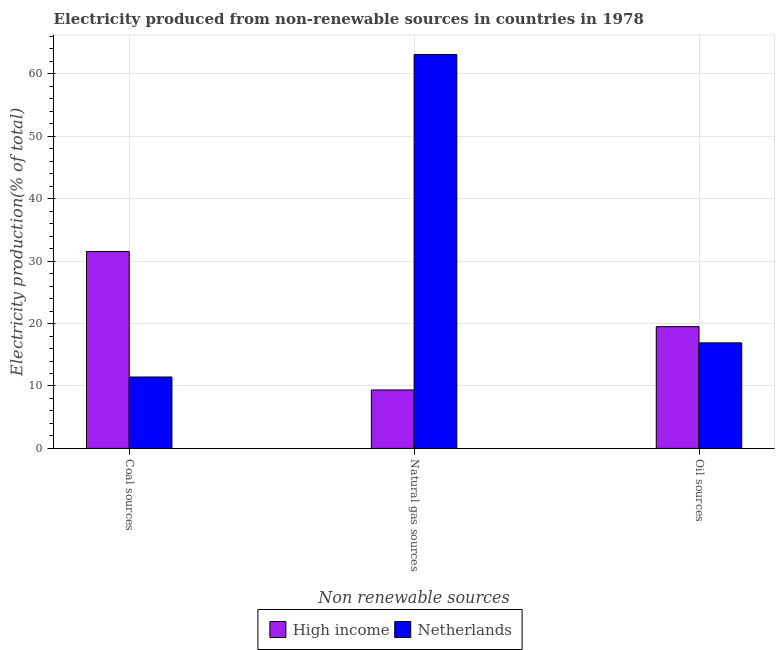How many different coloured bars are there?
Offer a very short reply. 2. What is the label of the 1st group of bars from the left?
Give a very brief answer. Coal sources. What is the percentage of electricity produced by coal in High income?
Offer a terse response. 31.54. Across all countries, what is the maximum percentage of electricity produced by coal?
Offer a very short reply. 31.54. Across all countries, what is the minimum percentage of electricity produced by natural gas?
Offer a terse response. 9.36. In which country was the percentage of electricity produced by natural gas maximum?
Ensure brevity in your answer.  Netherlands. In which country was the percentage of electricity produced by oil sources minimum?
Give a very brief answer. Netherlands. What is the total percentage of electricity produced by natural gas in the graph?
Offer a terse response. 72.46. What is the difference between the percentage of electricity produced by coal in Netherlands and that in High income?
Your response must be concise. -20.11. What is the difference between the percentage of electricity produced by natural gas in Netherlands and the percentage of electricity produced by oil sources in High income?
Provide a short and direct response. 43.59. What is the average percentage of electricity produced by natural gas per country?
Offer a terse response. 36.23. What is the difference between the percentage of electricity produced by coal and percentage of electricity produced by oil sources in Netherlands?
Provide a short and direct response. -5.47. In how many countries, is the percentage of electricity produced by natural gas greater than 14 %?
Provide a short and direct response. 1. What is the ratio of the percentage of electricity produced by natural gas in Netherlands to that in High income?
Make the answer very short. 6.74. Is the difference between the percentage of electricity produced by oil sources in High income and Netherlands greater than the difference between the percentage of electricity produced by coal in High income and Netherlands?
Your response must be concise. No. What is the difference between the highest and the second highest percentage of electricity produced by oil sources?
Give a very brief answer. 2.6. What is the difference between the highest and the lowest percentage of electricity produced by natural gas?
Ensure brevity in your answer.  53.73. In how many countries, is the percentage of electricity produced by natural gas greater than the average percentage of electricity produced by natural gas taken over all countries?
Offer a very short reply. 1. What does the 2nd bar from the left in Oil sources represents?
Make the answer very short. Netherlands. What does the 2nd bar from the right in Coal sources represents?
Make the answer very short. High income. Is it the case that in every country, the sum of the percentage of electricity produced by coal and percentage of electricity produced by natural gas is greater than the percentage of electricity produced by oil sources?
Offer a terse response. Yes. How many countries are there in the graph?
Provide a short and direct response. 2. What is the difference between two consecutive major ticks on the Y-axis?
Give a very brief answer. 10. Are the values on the major ticks of Y-axis written in scientific E-notation?
Offer a very short reply. No. Does the graph contain any zero values?
Provide a succinct answer. No. Where does the legend appear in the graph?
Make the answer very short. Bottom center. How are the legend labels stacked?
Provide a succinct answer. Horizontal. What is the title of the graph?
Your answer should be very brief. Electricity produced from non-renewable sources in countries in 1978. Does "Cuba" appear as one of the legend labels in the graph?
Offer a very short reply. No. What is the label or title of the X-axis?
Offer a very short reply. Non renewable sources. What is the Electricity production(% of total) of High income in Coal sources?
Ensure brevity in your answer.  31.54. What is the Electricity production(% of total) of Netherlands in Coal sources?
Your answer should be very brief. 11.44. What is the Electricity production(% of total) of High income in Natural gas sources?
Make the answer very short. 9.36. What is the Electricity production(% of total) in Netherlands in Natural gas sources?
Keep it short and to the point. 63.1. What is the Electricity production(% of total) of High income in Oil sources?
Provide a short and direct response. 19.51. What is the Electricity production(% of total) of Netherlands in Oil sources?
Your answer should be very brief. 16.91. Across all Non renewable sources, what is the maximum Electricity production(% of total) of High income?
Offer a terse response. 31.54. Across all Non renewable sources, what is the maximum Electricity production(% of total) of Netherlands?
Give a very brief answer. 63.1. Across all Non renewable sources, what is the minimum Electricity production(% of total) in High income?
Make the answer very short. 9.36. Across all Non renewable sources, what is the minimum Electricity production(% of total) of Netherlands?
Offer a very short reply. 11.44. What is the total Electricity production(% of total) of High income in the graph?
Provide a succinct answer. 60.42. What is the total Electricity production(% of total) of Netherlands in the graph?
Make the answer very short. 91.44. What is the difference between the Electricity production(% of total) in High income in Coal sources and that in Natural gas sources?
Give a very brief answer. 22.18. What is the difference between the Electricity production(% of total) in Netherlands in Coal sources and that in Natural gas sources?
Ensure brevity in your answer.  -51.66. What is the difference between the Electricity production(% of total) of High income in Coal sources and that in Oil sources?
Provide a short and direct response. 12.04. What is the difference between the Electricity production(% of total) of Netherlands in Coal sources and that in Oil sources?
Your answer should be very brief. -5.47. What is the difference between the Electricity production(% of total) of High income in Natural gas sources and that in Oil sources?
Make the answer very short. -10.14. What is the difference between the Electricity production(% of total) of Netherlands in Natural gas sources and that in Oil sources?
Provide a short and direct response. 46.19. What is the difference between the Electricity production(% of total) in High income in Coal sources and the Electricity production(% of total) in Netherlands in Natural gas sources?
Provide a short and direct response. -31.55. What is the difference between the Electricity production(% of total) in High income in Coal sources and the Electricity production(% of total) in Netherlands in Oil sources?
Your answer should be compact. 14.64. What is the difference between the Electricity production(% of total) in High income in Natural gas sources and the Electricity production(% of total) in Netherlands in Oil sources?
Provide a short and direct response. -7.54. What is the average Electricity production(% of total) in High income per Non renewable sources?
Offer a terse response. 20.14. What is the average Electricity production(% of total) in Netherlands per Non renewable sources?
Offer a terse response. 30.48. What is the difference between the Electricity production(% of total) in High income and Electricity production(% of total) in Netherlands in Coal sources?
Provide a succinct answer. 20.11. What is the difference between the Electricity production(% of total) of High income and Electricity production(% of total) of Netherlands in Natural gas sources?
Give a very brief answer. -53.73. What is the difference between the Electricity production(% of total) in High income and Electricity production(% of total) in Netherlands in Oil sources?
Ensure brevity in your answer.  2.6. What is the ratio of the Electricity production(% of total) of High income in Coal sources to that in Natural gas sources?
Ensure brevity in your answer.  3.37. What is the ratio of the Electricity production(% of total) in Netherlands in Coal sources to that in Natural gas sources?
Provide a short and direct response. 0.18. What is the ratio of the Electricity production(% of total) of High income in Coal sources to that in Oil sources?
Your answer should be compact. 1.62. What is the ratio of the Electricity production(% of total) of Netherlands in Coal sources to that in Oil sources?
Offer a terse response. 0.68. What is the ratio of the Electricity production(% of total) of High income in Natural gas sources to that in Oil sources?
Give a very brief answer. 0.48. What is the ratio of the Electricity production(% of total) of Netherlands in Natural gas sources to that in Oil sources?
Provide a short and direct response. 3.73. What is the difference between the highest and the second highest Electricity production(% of total) in High income?
Provide a short and direct response. 12.04. What is the difference between the highest and the second highest Electricity production(% of total) of Netherlands?
Make the answer very short. 46.19. What is the difference between the highest and the lowest Electricity production(% of total) of High income?
Offer a terse response. 22.18. What is the difference between the highest and the lowest Electricity production(% of total) in Netherlands?
Keep it short and to the point. 51.66. 